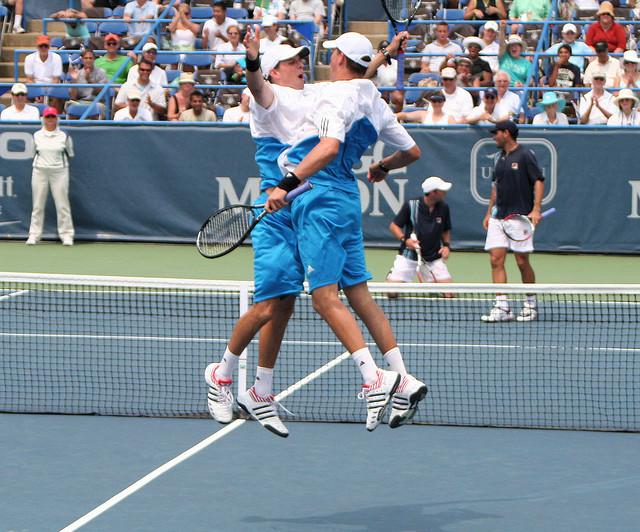What is the pop culture term for what the men in the foreground are doing?
Answer briefly. Chest bump. Which sport is this?
Quick response, please. Tennis. What color is the top of the net?
Keep it brief. White. 